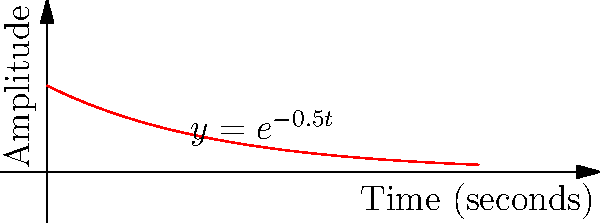As a pianist, you're studying the decay of piano notes over time. The amplitude $A$ of a particular note as a function of time $t$ (in seconds) is given by $A(t) = e^{-0.5t}$. Calculate the total amplitude experienced over the first 5 seconds after the note is struck. Express your answer in terms of $e$. Let's approach this step-by-step:

1) The total amplitude over time is represented by the area under the curve $A(t) = e^{-0.5t}$ from $t=0$ to $t=5$.

2) This area can be calculated using a definite integral:

   $$\int_0^5 e^{-0.5t} dt$$

3) To solve this integral, we can use the following antiderivative:

   $$\int e^{-0.5t} dt = -2e^{-0.5t} + C$$

4) Now, let's apply the fundamental theorem of calculus:

   $$[-2e^{-0.5t}]_0^5 = -2e^{-0.5(5)} - (-2e^{-0.5(0)})$$

5) Simplify:
   
   $$= -2e^{-2.5} - (-2)$$
   $$= -2e^{-2.5} + 2$$

6) This can be written as:

   $$2(1 - e^{-2.5})$$

This is our final answer, representing the total amplitude experienced over the first 5 seconds.
Answer: $2(1 - e^{-2.5})$ 